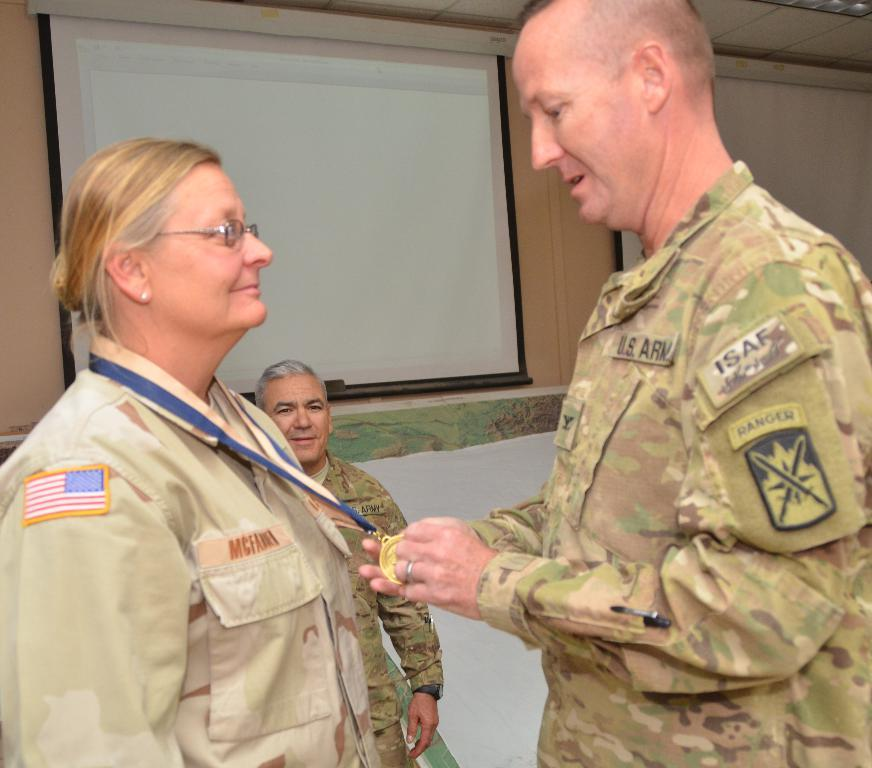How many people are present in the image? There are three people in the image. Can you describe the attire of one of the individuals? A woman is wearing a medal. What can be seen in the background of the image? There is a wall, a ceiling, and screens in the background of the image. What type of dime can be seen on the floor in the image? There is no dime present on the floor in the image. Is the scene taking place during winter in the image? The image does not provide any information about the season, so it cannot be determined if it is winter. 